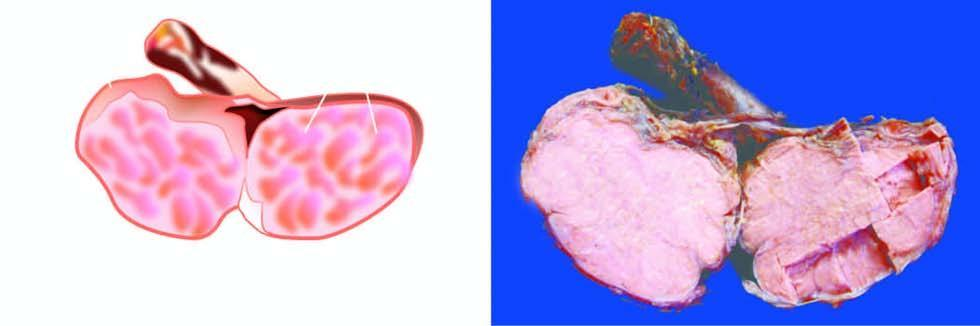does central coagulative necrosis show replacement of the entire testis by lobulated, homogeneous, grey-white mass?
Answer the question using a single word or phrase. No 